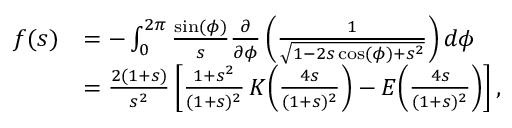Convert formula to latex. <formula><loc_0><loc_0><loc_500><loc_500>\begin{array} { r l } { f ( s ) } & { = - \int _ { 0 } ^ { 2 \pi } \frac { \sin ( \phi ) } { s } \frac { \partial } { \partial \phi } \left ( \frac { 1 } { \sqrt { 1 - 2 s \cos ( \phi ) + s ^ { 2 } } } \right ) d \phi } \\ & { = \frac { 2 ( 1 + s ) } { s ^ { 2 } } \left [ \frac { 1 + s ^ { 2 } } { ( 1 + s ) ^ { 2 } } \, K \, \left ( \frac { 4 s } { ( 1 + s ) ^ { 2 } } \right ) - E \, \left ( \frac { 4 s } { ( 1 + s ) ^ { 2 } } \right ) \right ] , } \end{array}</formula> 